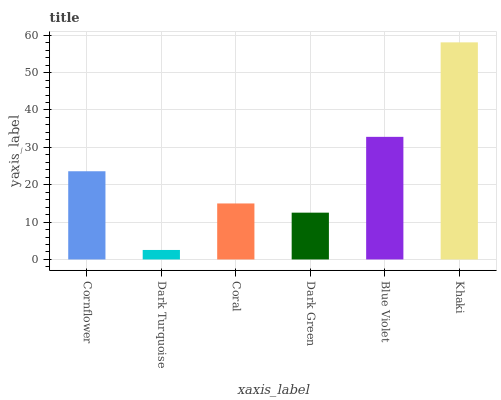Is Dark Turquoise the minimum?
Answer yes or no. Yes. Is Khaki the maximum?
Answer yes or no. Yes. Is Coral the minimum?
Answer yes or no. No. Is Coral the maximum?
Answer yes or no. No. Is Coral greater than Dark Turquoise?
Answer yes or no. Yes. Is Dark Turquoise less than Coral?
Answer yes or no. Yes. Is Dark Turquoise greater than Coral?
Answer yes or no. No. Is Coral less than Dark Turquoise?
Answer yes or no. No. Is Cornflower the high median?
Answer yes or no. Yes. Is Coral the low median?
Answer yes or no. Yes. Is Blue Violet the high median?
Answer yes or no. No. Is Dark Green the low median?
Answer yes or no. No. 